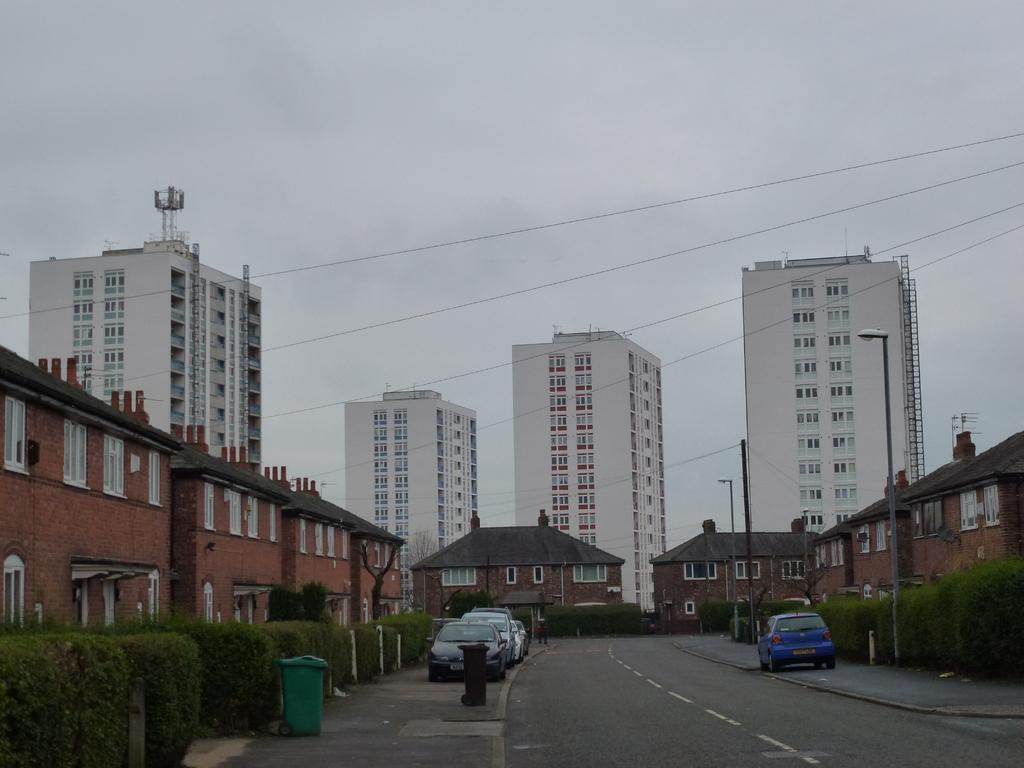How would you summarize this image in a sentence or two? In this image I can see number of buildings, number of windows, wires, bushes, green colour container, few vehicles, white colour lines on this road and I can also see few street lights. 